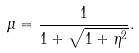Convert formula to latex. <formula><loc_0><loc_0><loc_500><loc_500>\mu = \frac { 1 } { 1 + \sqrt { 1 + \eta ^ { 2 } } } .</formula> 